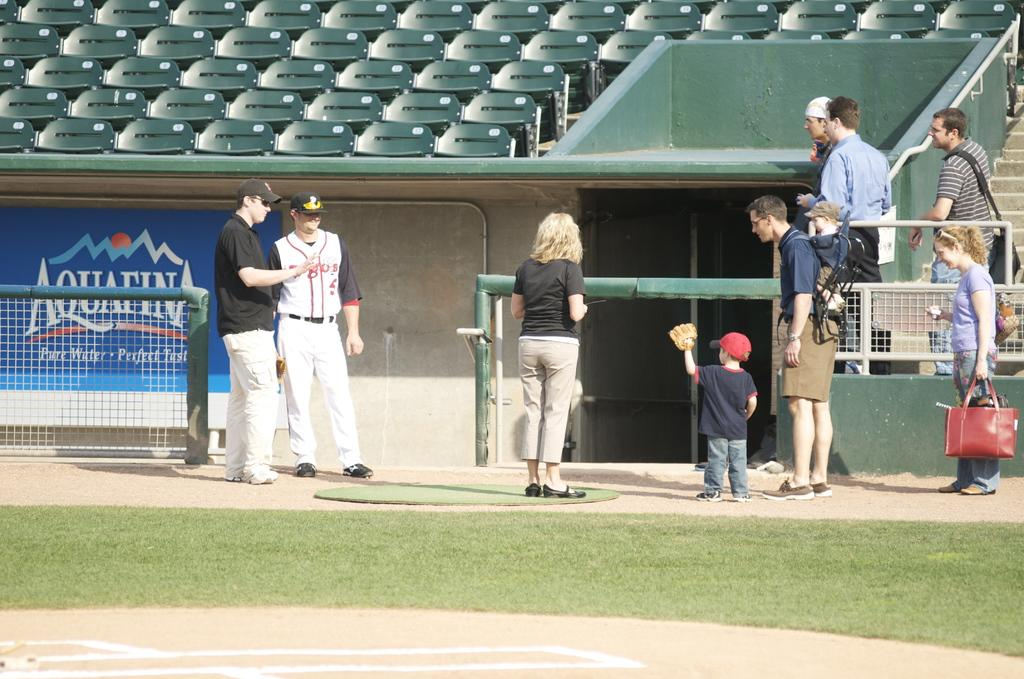Provide a one-sentence caption for the provided image. An advertisement for Aquafina water hangs near the dugout of a baseball field. 